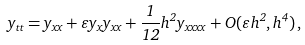<formula> <loc_0><loc_0><loc_500><loc_500>y _ { t t } = y _ { x x } + \varepsilon y _ { x } y _ { x x } + \frac { 1 } { 1 2 } h ^ { 2 } y _ { x x x x } + O ( \varepsilon h ^ { 2 } , h ^ { 4 } ) \, ,</formula> 